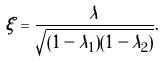<formula> <loc_0><loc_0><loc_500><loc_500>\xi = \frac { \lambda } { \sqrt { ( 1 - \lambda _ { 1 } ) ( 1 - \lambda _ { 2 } ) } } .</formula> 